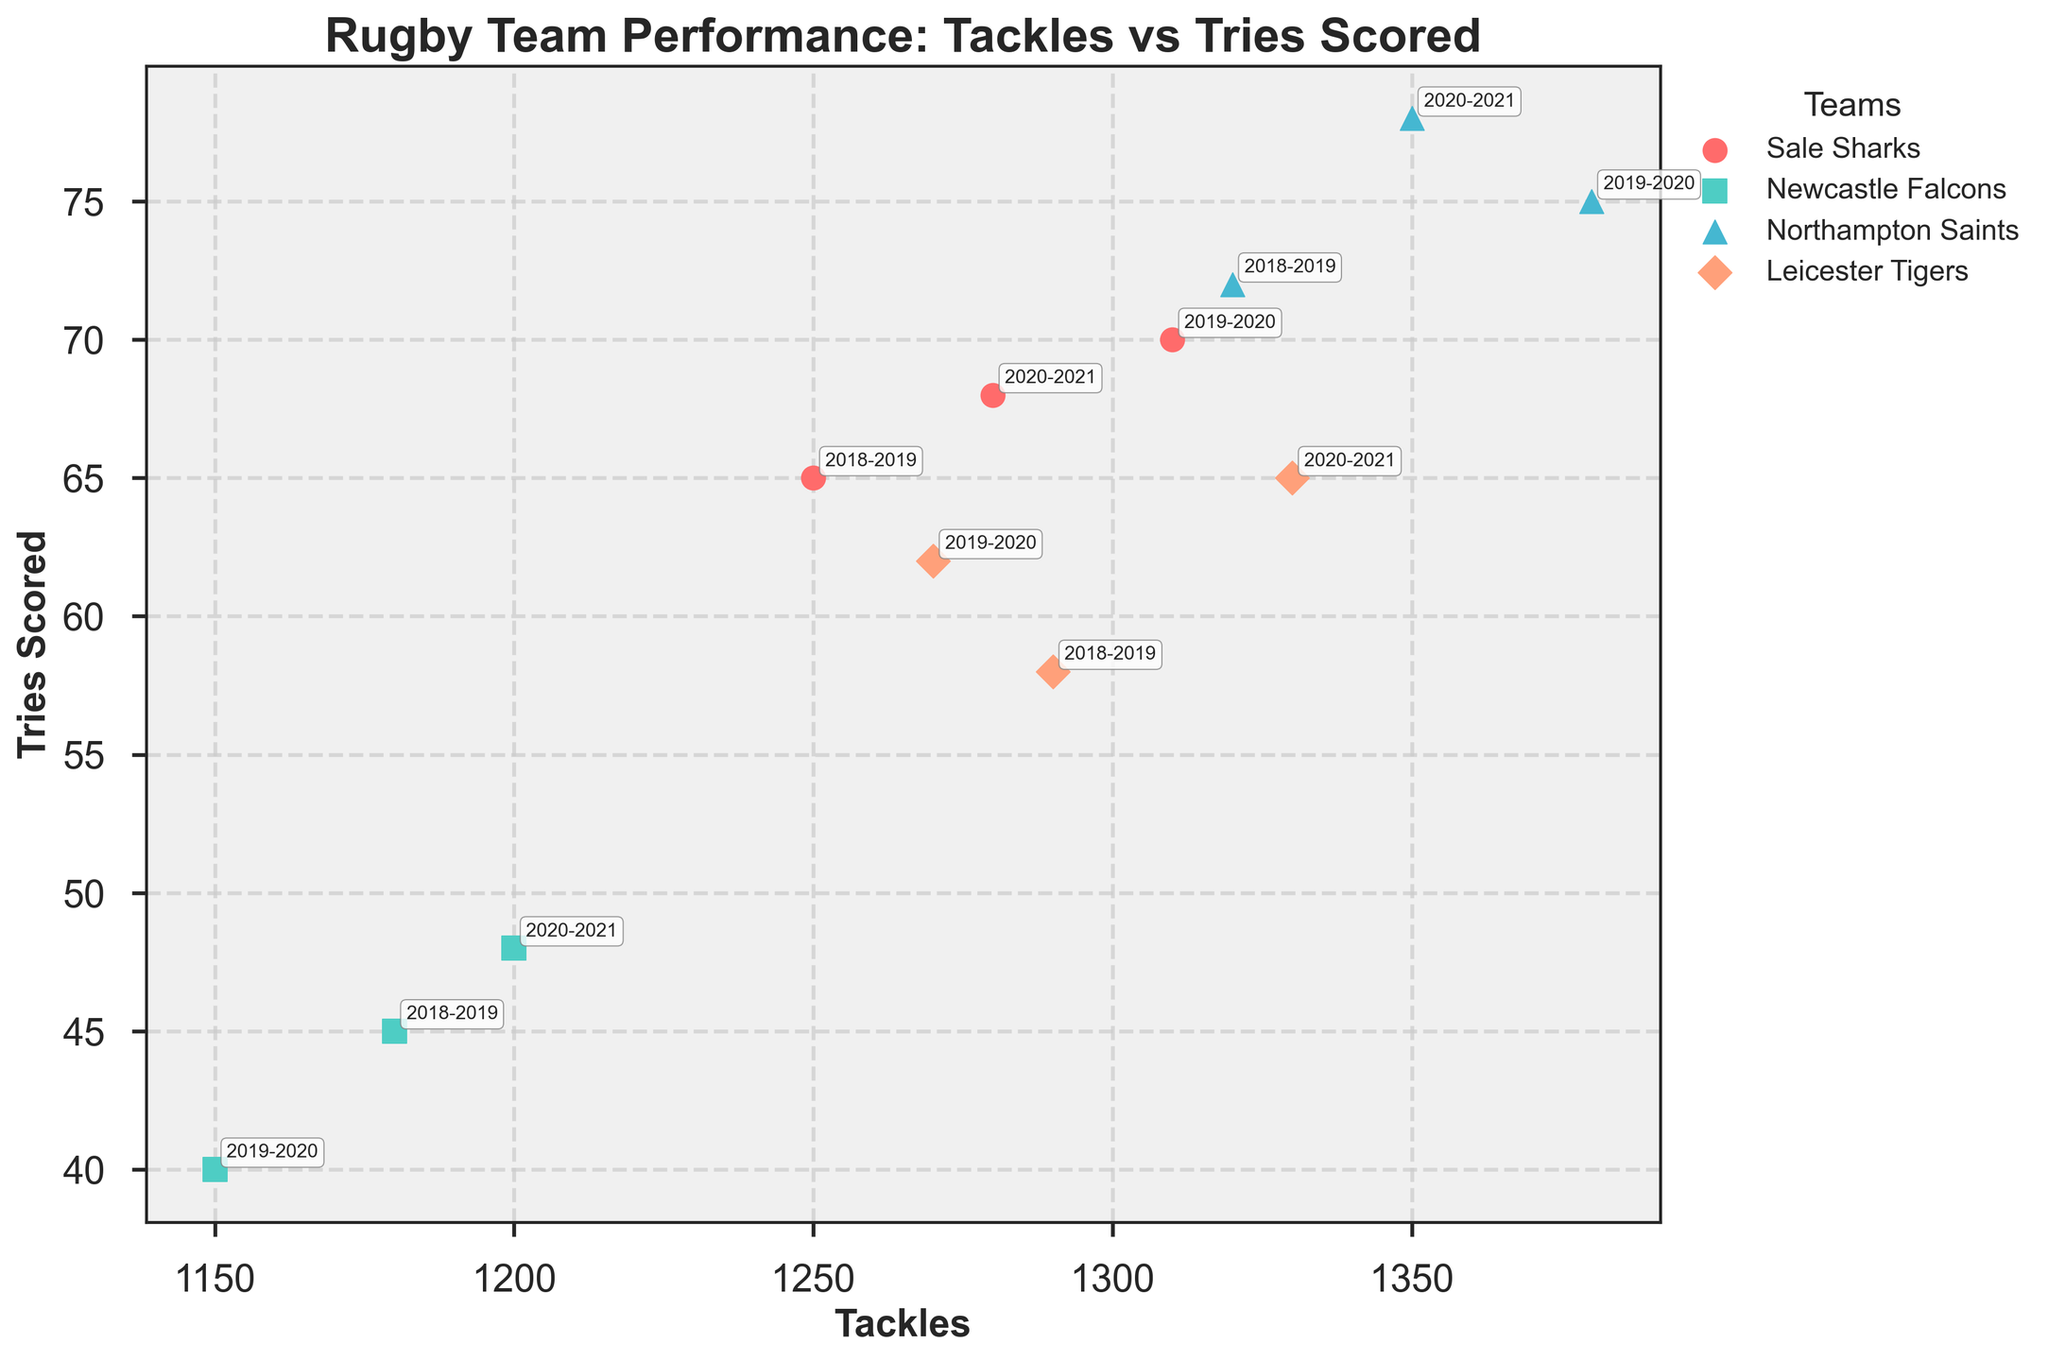Which team has the highest number of tries scored in the 2020-2021 season? Look at the data points labeled "2020-2021" and find the team corresponding to the highest "Tries Scored" value. Northampton Saints have 78 tries scored in the 2020-2021 season.
Answer: Northampton Saints Which season did Newcastle Falcons record the lowest number of tackles? Review the scatter points for Newcastle Falcons and identify the season with the smallest "Tackles" value. In 2019-2020, Newcastle Falcons recorded 1150 tackles.
Answer: 2019-2020 How do Sale Sharks’ tries scored in 2018-2019 compare to 2019-2020? Find and compare the "Tries Scored" by Sale Sharks for the seasons 2018-2019 and 2019-2020. Sale Sharks scored 65 tries in 2018-2019 and 70 tries in 2019-2020.
Answer: 70 tries in 2019-2020 is higher than 65 tries in 2018-2019 Which team showed an increase in both tackles and tries scored from 2018-2019 to 2019-2020? Look at the changes in "Tackles" and "Tries Scored" for each team between 2018-2019 and 2019-2020. Sale Sharks, with an increase from 1250 to 1310 tackles and 65 to 70 tries, showed improvement in both metrics.
Answer: Sale Sharks In which season did Leicester Tigers have the highest number of tries scored and how many were scored? Examine the data points for Leicester Tigers across the seasons to find the peak "Tries Scored" value and its respective season. In the 2019-2020 season, Leicester Tigers scored 62 tries.
Answer: 2019-2020; 62 tries What is the average number of tries scored by Northampton Saints across all seasons? Sum the total tries scored by Northampton Saints across the seasons and divide by the number of seasons. (72 + 75 + 78) / 3 = 75.
Answer: 75 Compare the tackles and tries scored by Northampton Saints and Newcastle Falcons in the 2018-2019 season. Which team performed better? Identify the "Tackles" and "Tries Scored" for both teams in the 2018-2019 season. Northampton Saints: 1320 tackles, 72 tries; Newcastle Falcons: 1180 tackles, 45 tries. Northampton Saints performed better in both metrics.
Answer: Northampton Saints In 2018-2019, which team had the least number of tries scored? Check the scatter points labeled "2018-2019" and compare the "Tries Scored" values to find the lowest. Newcastle Falcons scored the least with 45 tries.
Answer: Newcastle Falcons How did Leicester Tigers perform in terms of tackles in 2018-2019 compared to 2020-2021? Compare the "Tackles" by Leicester Tigers in 2018-2019 and 2020-2021. They recorded 1290 tackles in 2018-2019 and 1330 tackles in 2020-2021.
Answer: More tackles in 2020-2021 What is the median number of tackles across all teams and seasons in the plot? List the "Tackles" values, organize them in ascending order, and locate the middle value. (1150, 1180, 1200, 1250, 1270, 1280, 1290, 1310, 1320, 1330, 1350, 1380). The median of these 12 values is the average of the 6th and 7th values: (1270 + 1280) / 2 = 1275.
Answer: 1275 